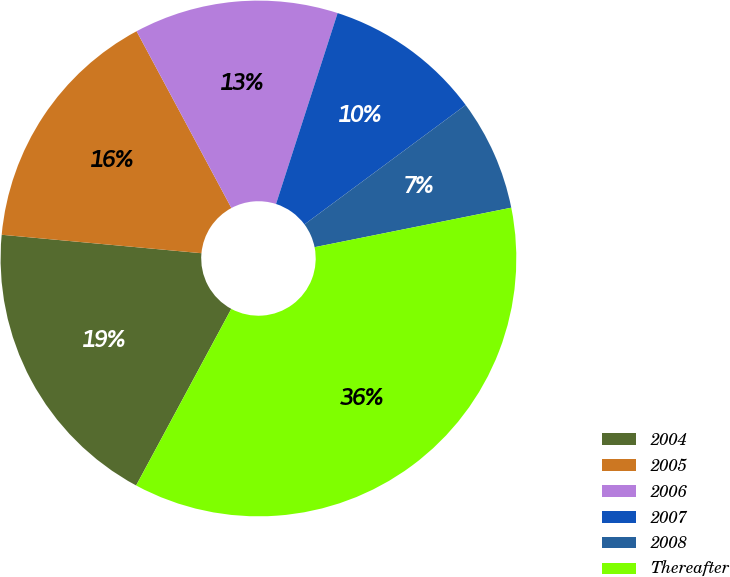Convert chart to OTSL. <chart><loc_0><loc_0><loc_500><loc_500><pie_chart><fcel>2004<fcel>2005<fcel>2006<fcel>2007<fcel>2008<fcel>Thereafter<nl><fcel>18.6%<fcel>15.7%<fcel>12.8%<fcel>9.89%<fcel>6.99%<fcel>36.02%<nl></chart> 